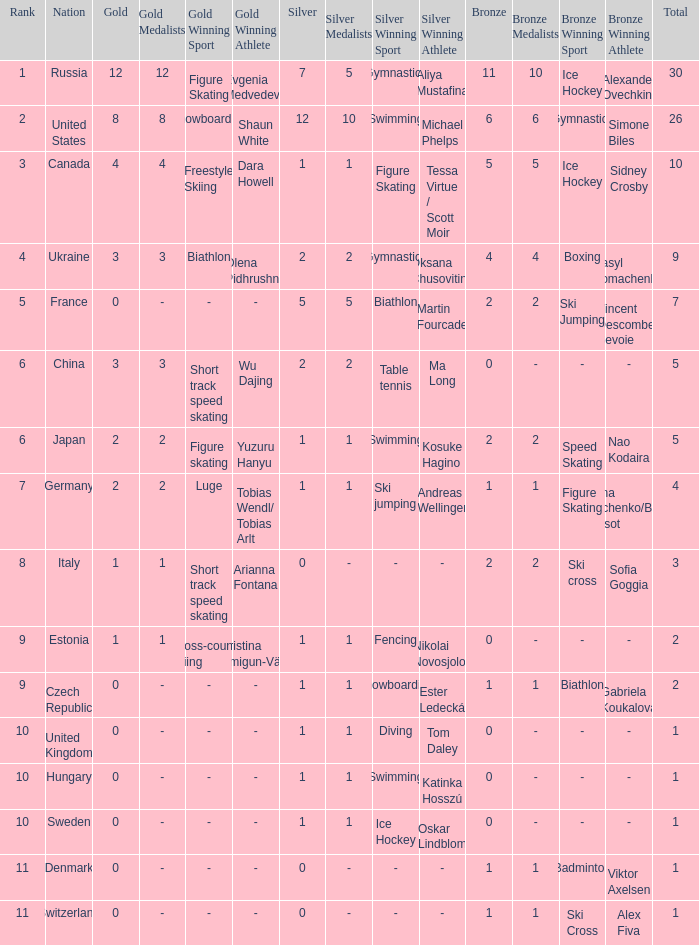Can you parse all the data within this table? {'header': ['Rank', 'Nation', 'Gold', 'Gold Medalists', 'Gold Winning Sport', 'Gold Winning Athlete', 'Silver', 'Silver Medalists', 'Silver Winning Sport', 'Silver Winning Athlete', 'Bronze', 'Bronze Medalists', 'Bronze Winning Sport', 'Bronze Winning Athlete', 'Total'], 'rows': [['1', 'Russia', '12', '12', 'Figure Skating', 'Evgenia Medvedeva', '7', '5', 'Gymnastics', 'Aliya Mustafina', '11', '10', 'Ice Hockey', 'Alexander Ovechkin', '30'], ['2', 'United States', '8', '8', 'Snowboarding', 'Shaun White', '12', '10', 'Swimming', 'Michael Phelps', '6', '6', 'Gymnastics', 'Simone Biles', '26'], ['3', 'Canada', '4', '4', 'Freestyle Skiing', 'Dara Howell', '1', '1', 'Figure Skating', 'Tessa Virtue / Scott Moir', '5', '5', 'Ice Hockey', 'Sidney Crosby', '10'], ['4', 'Ukraine', '3', '3', 'Biathlon', 'Olena Pidhrushna', '2', '2', 'Gymnastics', 'Oksana Chusovitina', '4', '4', 'Boxing', 'Vasyl Lomachenko', '9'], ['5', 'France', '0', '-', '-', '-', '5', '5', 'Biathlon', 'Martin Fourcade', '2', '2', 'Ski Jumping', 'Vincent Descombes Sevoie', '7'], ['6', 'China', '3', '3', 'Short track speed skating', 'Wu Dajing', '2', '2', 'Table tennis', 'Ma Long', '0', '-', '-', '-', '5'], ['6', 'Japan', '2', '2', 'Figure skating', 'Yuzuru Hanyu', '1', '1', 'Swimming', 'Kosuke Hagino', '2', '2', 'Speed Skating', 'Nao Kodaira', '5'], ['7', 'Germany', '2', '2', 'Luge', 'Tobias Wendl/ Tobias Arlt', '1', '1', 'Ski jumping', 'Andreas Wellinger', '1', '1', 'Figure Skating', 'Aljona Savchenko/Bruno Massot', '4'], ['8', 'Italy', '1', '1', 'Short track speed skating', 'Arianna Fontana', '0', '-', '-', '-', '2', '2', 'Ski cross', 'Sofia Goggia', '3'], ['9', 'Estonia', '1', '1', 'Cross-country skiing', 'Kristina Šmigun-Vähi', '1', '1', 'Fencing', 'Nikolai Novosjolov', '0', '-', '-', '-', '2'], ['9', 'Czech Republic', '0', '-', '-', '-', '1', '1', 'Snowboarding', 'Ester Ledecká', '1', '1', 'Biathlon', 'Gabriela Koukalová', '2'], ['10', 'United Kingdom', '0', '-', '-', '-', '1', '1', 'Diving', 'Tom Daley', '0', '-', '-', '-', '1'], ['10', 'Hungary', '0', '-', '-', '-', '1', '1', 'Swimming', 'Katinka Hosszú', '0', '-', '-', '-', '1'], ['10', 'Sweden', '0', '-', '-', '-', '1', '1', 'Ice Hockey', 'Oskar Lindblom', '0', '-', '-', '-', '1'], ['11', 'Denmark', '0', '-', '-', '-', '0', '-', '-', '-', '1', '1', 'Badminton', 'Viktor Axelsen', '1'], ['11', 'Switzerland', '0', '-', '-', '-', '0', '-', '-', '-', '1', '1', 'Ski Cross', 'Alex Fiva', '1']]} Which silver has a Gold smaller than 12, a Rank smaller than 5, and a Bronze of 5? 1.0. 